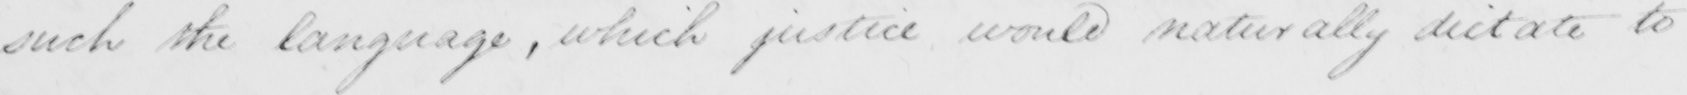What is written in this line of handwriting? -such the language , which justice would naturally dictate to 